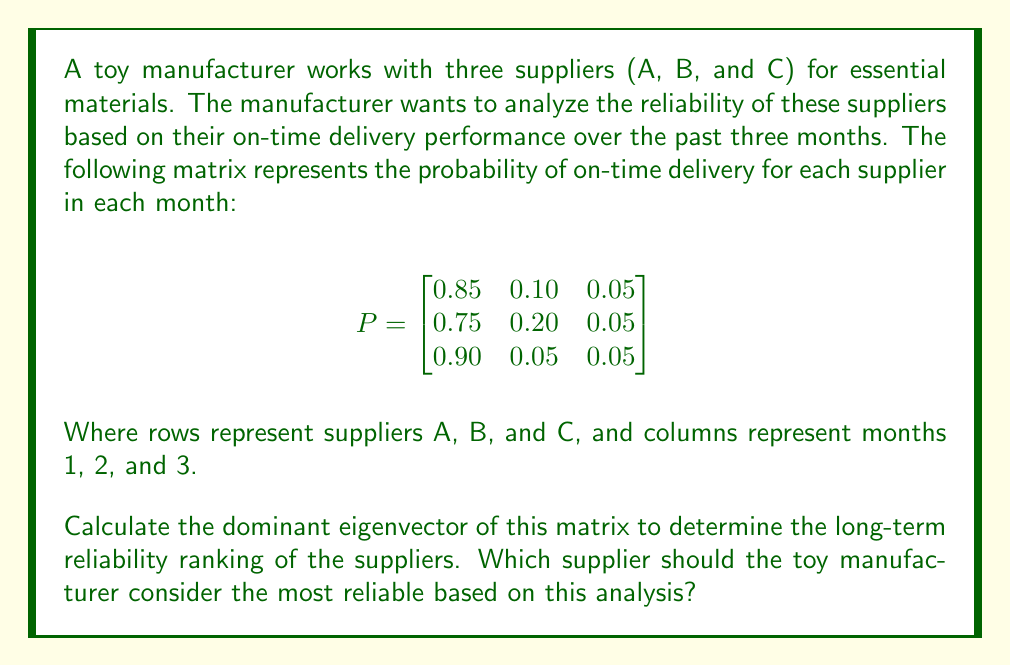Show me your answer to this math problem. To solve this problem, we need to follow these steps:

1. Find the eigenvalues of the matrix P.
2. Identify the dominant eigenvalue (the largest one).
3. Calculate the eigenvector corresponding to the dominant eigenvalue.
4. Normalize the eigenvector to get the long-term reliability ranking.

Step 1: Find the eigenvalues
To find the eigenvalues, we need to solve the characteristic equation:
$\det(P - \lambda I) = 0$

$$\begin{vmatrix}
0.85-\lambda & 0.10 & 0.05 \\
0.75 & 0.20-\lambda & 0.05 \\
0.90 & 0.05 & 0.05-\lambda
\end{vmatrix} = 0$$

Solving this equation gives us the eigenvalues:
$\lambda_1 = 1$, $\lambda_2 \approx 0.0789$, $\lambda_3 \approx 0.0211$

Step 2: Identify the dominant eigenvalue
The dominant eigenvalue is $\lambda_1 = 1$.

Step 3: Calculate the eigenvector for $\lambda_1 = 1$
We need to solve $(P - I)\vec{v} = \vec{0}$:

$$\begin{bmatrix}
-0.15 & 0.10 & 0.05 \\
0.75 & -0.80 & 0.05 \\
0.90 & 0.05 & -0.95
\end{bmatrix}\begin{bmatrix}
v_1 \\ v_2 \\ v_3
\end{bmatrix} = \begin{bmatrix}
0 \\ 0 \\ 0
\end{bmatrix}$$

Solving this system of equations, we get:
$v_1 : v_2 : v_3 = 18 : 15 : 17$

Step 4: Normalize the eigenvector
To normalize, we divide each component by the sum of all components:

$$\vec{v} = \frac{1}{18+15+17}\begin{bmatrix}
18 \\ 15 \\ 17
\end{bmatrix} = \begin{bmatrix}
0.36 \\ 0.30 \\ 0.34
\end{bmatrix}$$

This normalized eigenvector represents the long-term reliability ranking of the suppliers. Supplier A (0.36) has the highest reliability, followed by Supplier C (0.34), and then Supplier B (0.30).
Answer: Supplier A (36% reliability) 